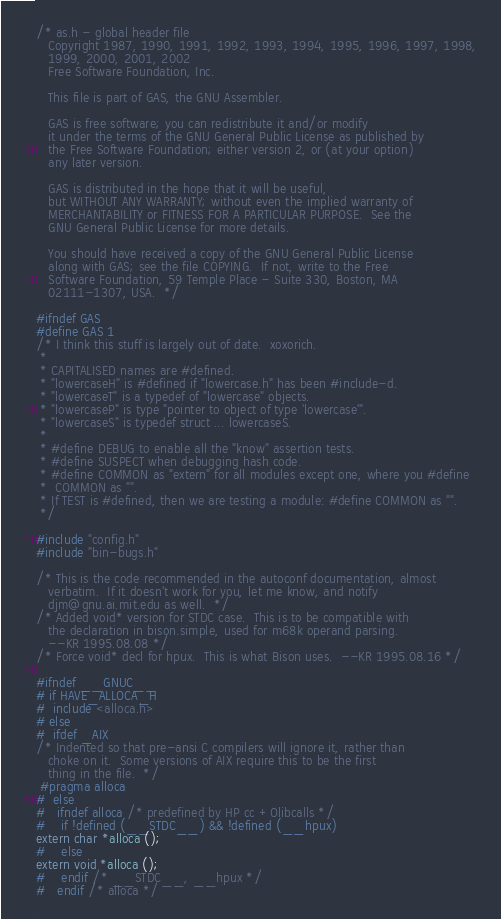<code> <loc_0><loc_0><loc_500><loc_500><_C_>/* as.h - global header file
   Copyright 1987, 1990, 1991, 1992, 1993, 1994, 1995, 1996, 1997, 1998,
   1999, 2000, 2001, 2002
   Free Software Foundation, Inc.

   This file is part of GAS, the GNU Assembler.

   GAS is free software; you can redistribute it and/or modify
   it under the terms of the GNU General Public License as published by
   the Free Software Foundation; either version 2, or (at your option)
   any later version.

   GAS is distributed in the hope that it will be useful,
   but WITHOUT ANY WARRANTY; without even the implied warranty of
   MERCHANTABILITY or FITNESS FOR A PARTICULAR PURPOSE.  See the
   GNU General Public License for more details.

   You should have received a copy of the GNU General Public License
   along with GAS; see the file COPYING.  If not, write to the Free
   Software Foundation, 59 Temple Place - Suite 330, Boston, MA
   02111-1307, USA.  */

#ifndef GAS
#define GAS 1
/* I think this stuff is largely out of date.  xoxorich.
 *
 * CAPITALISED names are #defined.
 * "lowercaseH" is #defined if "lowercase.h" has been #include-d.
 * "lowercaseT" is a typedef of "lowercase" objects.
 * "lowercaseP" is type "pointer to object of type 'lowercase'".
 * "lowercaseS" is typedef struct ... lowercaseS.
 *
 * #define DEBUG to enable all the "know" assertion tests.
 * #define SUSPECT when debugging hash code.
 * #define COMMON as "extern" for all modules except one, where you #define
 *	COMMON as "".
 * If TEST is #defined, then we are testing a module: #define COMMON as "".
 */

#include "config.h"
#include "bin-bugs.h"

/* This is the code recommended in the autoconf documentation, almost
   verbatim.  If it doesn't work for you, let me know, and notify
   djm@gnu.ai.mit.edu as well.  */
/* Added void* version for STDC case.  This is to be compatible with
   the declaration in bison.simple, used for m68k operand parsing.
   --KR 1995.08.08 */
/* Force void* decl for hpux.  This is what Bison uses.  --KR 1995.08.16 */

#ifndef __GNUC__
# if HAVE_ALLOCA_H
#  include <alloca.h>
# else
#  ifdef _AIX
/* Indented so that pre-ansi C compilers will ignore it, rather than
   choke on it.  Some versions of AIX require this to be the first
   thing in the file.  */
 #pragma alloca
#  else
#   ifndef alloca /* predefined by HP cc +Olibcalls */
#    if !defined (__STDC__) && !defined (__hpux)
extern char *alloca ();
#    else
extern void *alloca ();
#    endif /* __STDC__, __hpux */
#   endif /* alloca */</code> 